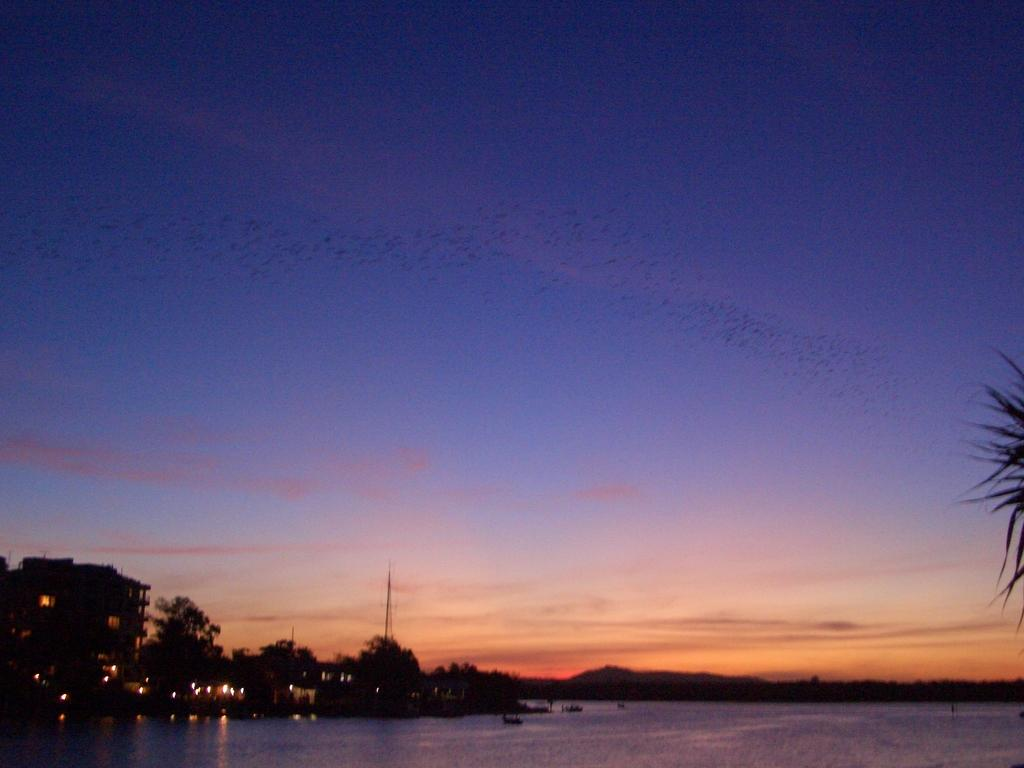What is visible in the image? Water is visible in the image. What can be seen on the right side of the image? There are leaves on the right side of the image. What is visible in the background of the image? There is a building, trees, a pole, lights, and the sky visible in the background of the image. Can you tell me how the wind is affecting the objects in the image? There is no mention of wind in the provided facts, and therefore we cannot determine its effect on the objects in the image. 